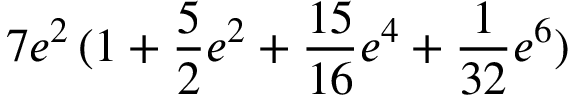Convert formula to latex. <formula><loc_0><loc_0><loc_500><loc_500>7 e ^ { 2 } \, ( 1 + \frac { 5 } { 2 } e ^ { 2 } + \frac { 1 5 } { 1 6 } e ^ { 4 } + \frac { 1 } { 3 2 } e ^ { 6 } )</formula> 